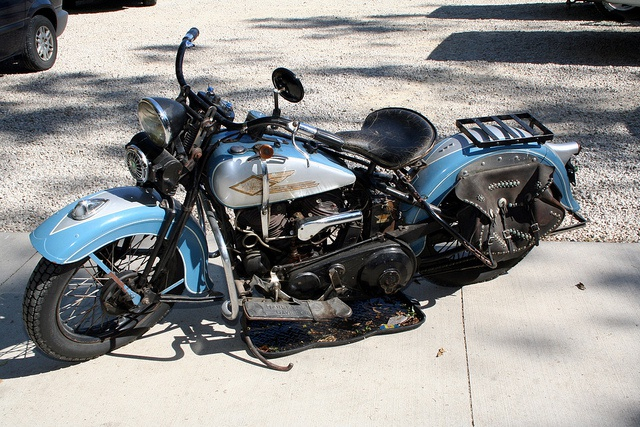Describe the objects in this image and their specific colors. I can see motorcycle in black, gray, darkgray, and lightgray tones and car in black, gray, and darkgray tones in this image. 